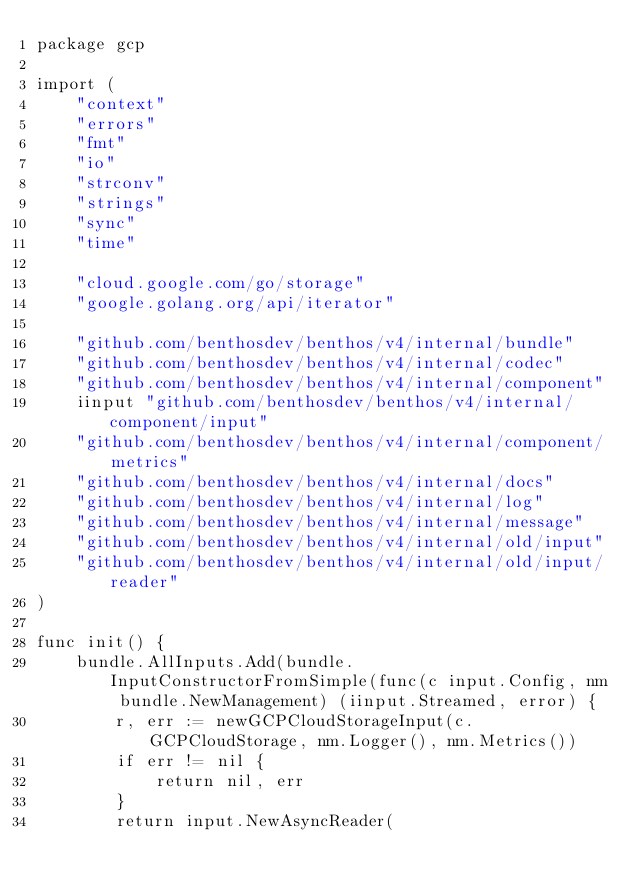<code> <loc_0><loc_0><loc_500><loc_500><_Go_>package gcp

import (
	"context"
	"errors"
	"fmt"
	"io"
	"strconv"
	"strings"
	"sync"
	"time"

	"cloud.google.com/go/storage"
	"google.golang.org/api/iterator"

	"github.com/benthosdev/benthos/v4/internal/bundle"
	"github.com/benthosdev/benthos/v4/internal/codec"
	"github.com/benthosdev/benthos/v4/internal/component"
	iinput "github.com/benthosdev/benthos/v4/internal/component/input"
	"github.com/benthosdev/benthos/v4/internal/component/metrics"
	"github.com/benthosdev/benthos/v4/internal/docs"
	"github.com/benthosdev/benthos/v4/internal/log"
	"github.com/benthosdev/benthos/v4/internal/message"
	"github.com/benthosdev/benthos/v4/internal/old/input"
	"github.com/benthosdev/benthos/v4/internal/old/input/reader"
)

func init() {
	bundle.AllInputs.Add(bundle.InputConstructorFromSimple(func(c input.Config, nm bundle.NewManagement) (iinput.Streamed, error) {
		r, err := newGCPCloudStorageInput(c.GCPCloudStorage, nm.Logger(), nm.Metrics())
		if err != nil {
			return nil, err
		}
		return input.NewAsyncReader(</code> 